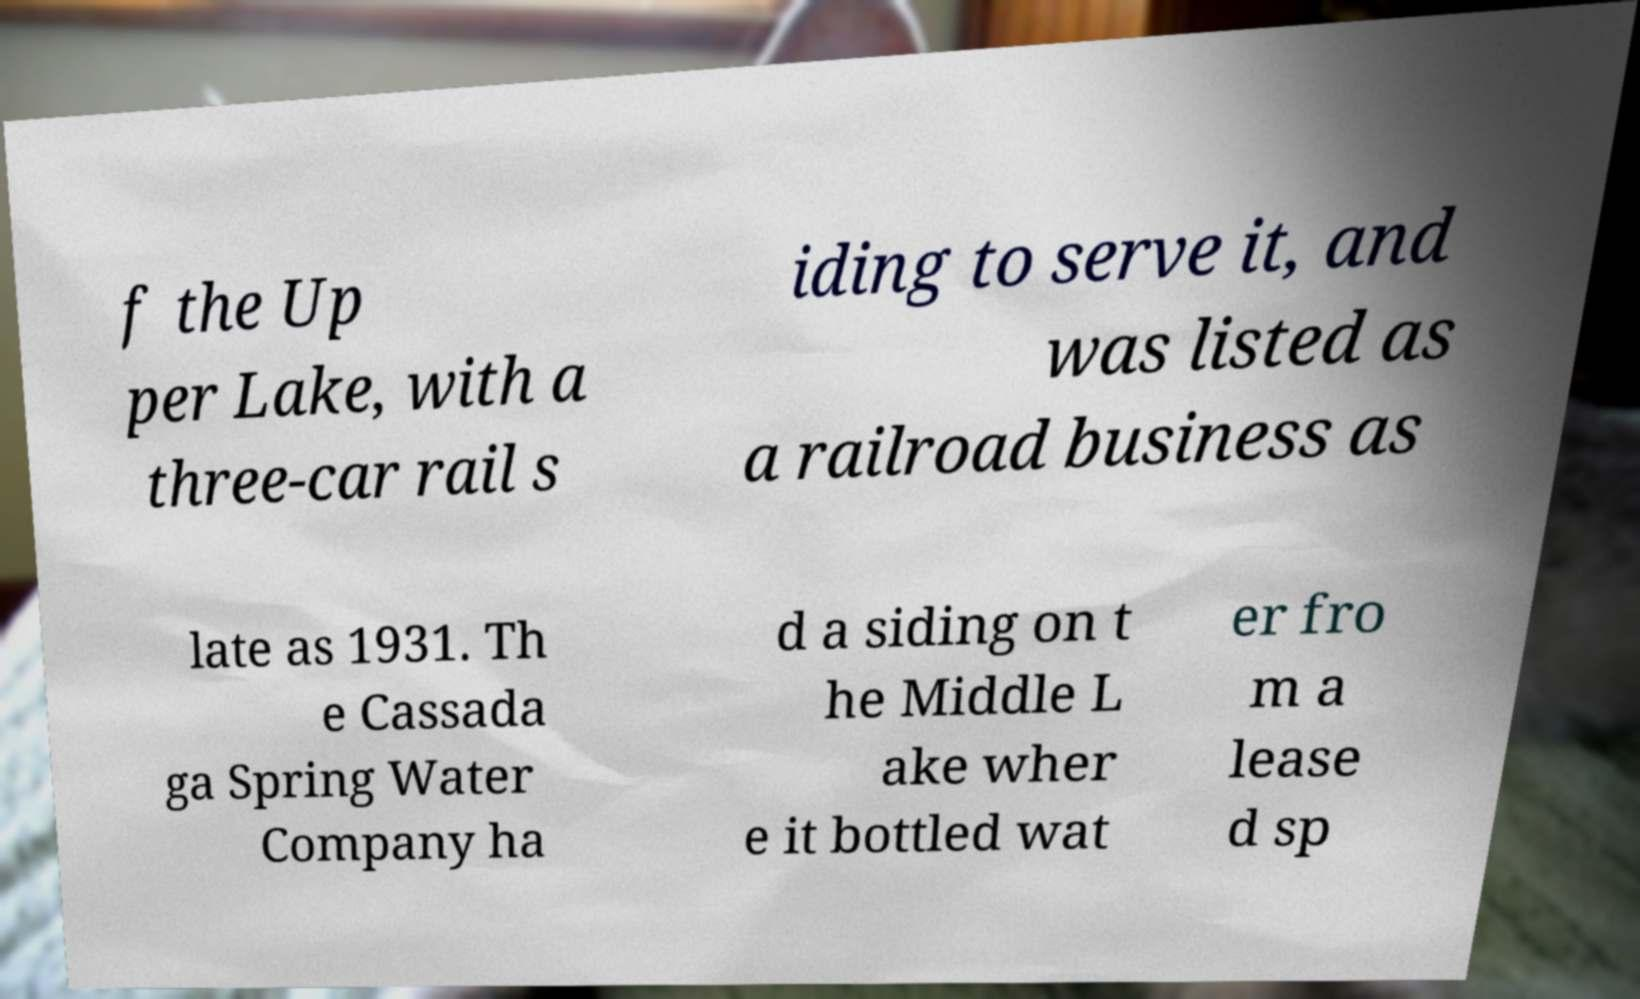Can you read and provide the text displayed in the image?This photo seems to have some interesting text. Can you extract and type it out for me? f the Up per Lake, with a three-car rail s iding to serve it, and was listed as a railroad business as late as 1931. Th e Cassada ga Spring Water Company ha d a siding on t he Middle L ake wher e it bottled wat er fro m a lease d sp 